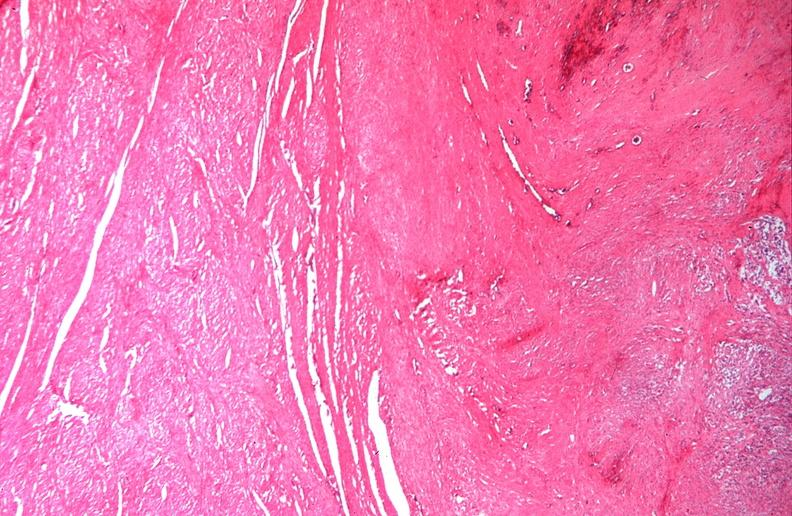does cervix duplication show uterus, leiomyomas?
Answer the question using a single word or phrase. No 